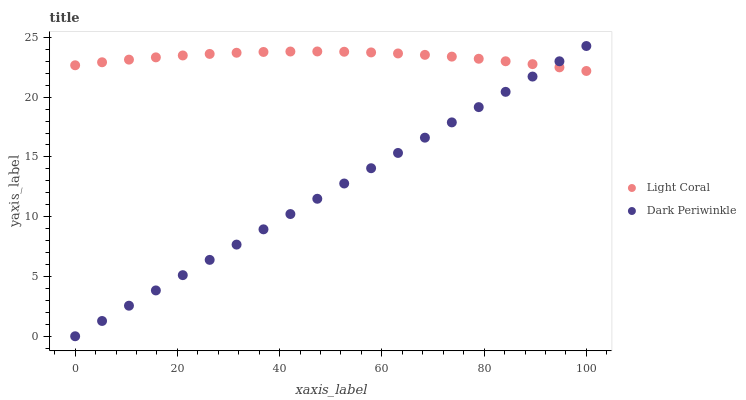Does Dark Periwinkle have the minimum area under the curve?
Answer yes or no. Yes. Does Light Coral have the maximum area under the curve?
Answer yes or no. Yes. Does Dark Periwinkle have the maximum area under the curve?
Answer yes or no. No. Is Dark Periwinkle the smoothest?
Answer yes or no. Yes. Is Light Coral the roughest?
Answer yes or no. Yes. Is Dark Periwinkle the roughest?
Answer yes or no. No. Does Dark Periwinkle have the lowest value?
Answer yes or no. Yes. Does Dark Periwinkle have the highest value?
Answer yes or no. Yes. Does Dark Periwinkle intersect Light Coral?
Answer yes or no. Yes. Is Dark Periwinkle less than Light Coral?
Answer yes or no. No. Is Dark Periwinkle greater than Light Coral?
Answer yes or no. No. 